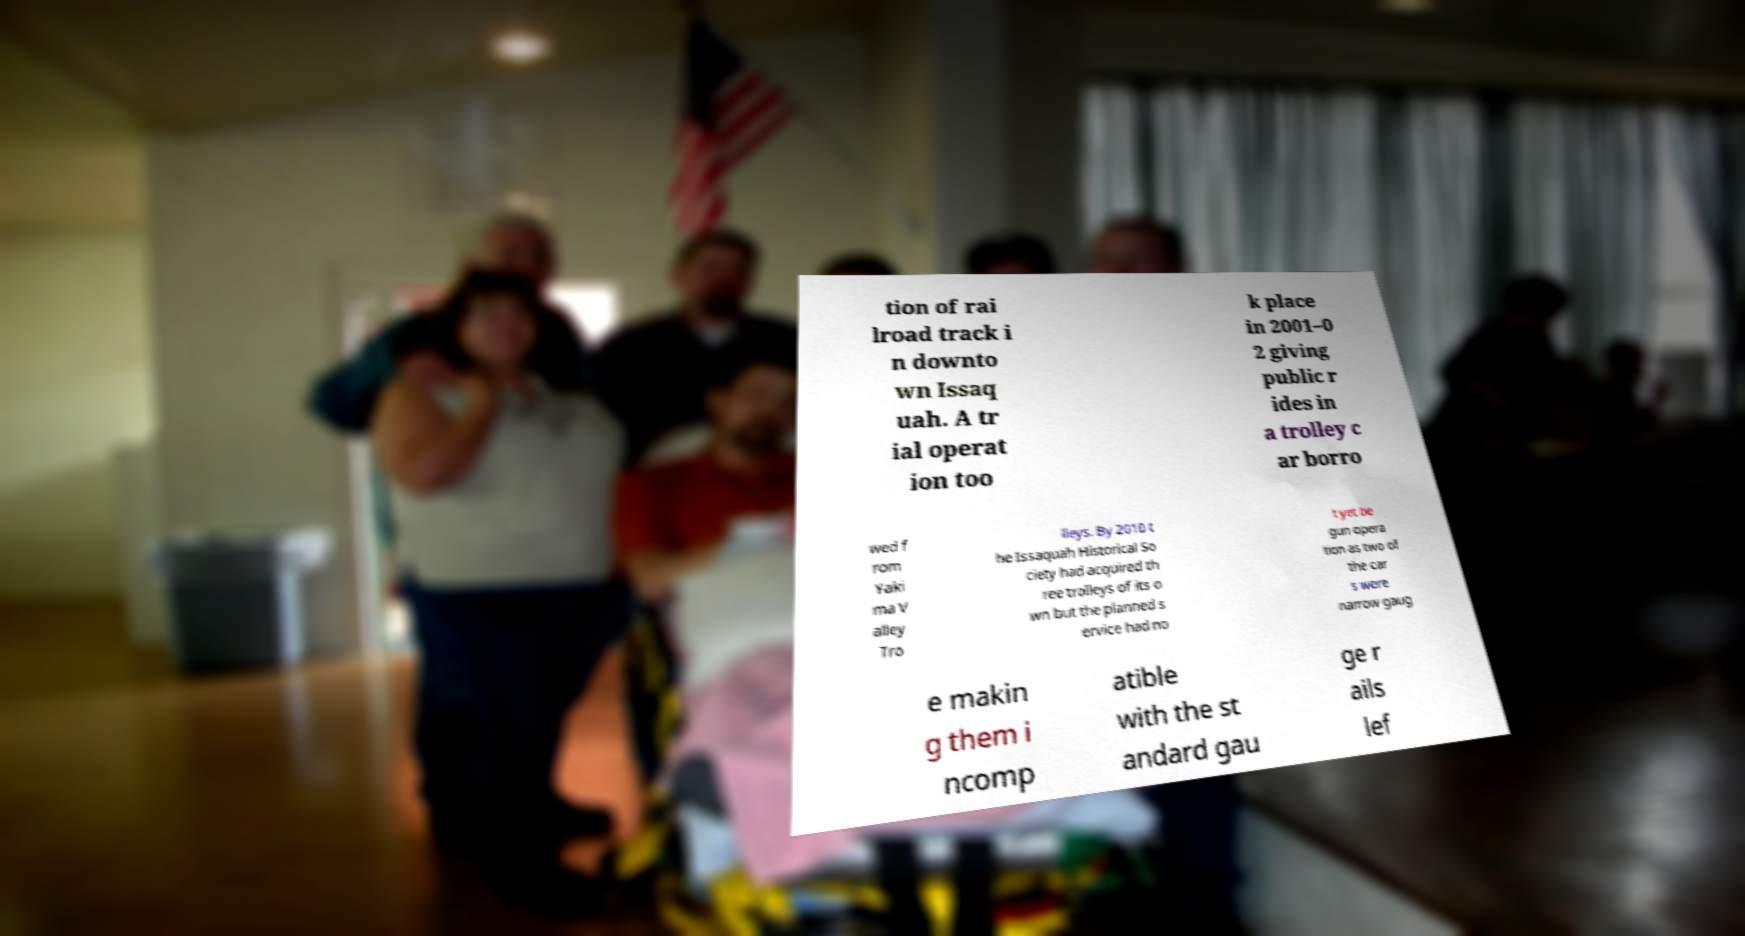I need the written content from this picture converted into text. Can you do that? tion of rai lroad track i n downto wn Issaq uah. A tr ial operat ion too k place in 2001–0 2 giving public r ides in a trolley c ar borro wed f rom Yaki ma V alley Tro lleys. By 2010 t he Issaquah Historical So ciety had acquired th ree trolleys of its o wn but the planned s ervice had no t yet be gun opera tion as two of the car s were narrow gaug e makin g them i ncomp atible with the st andard gau ge r ails lef 